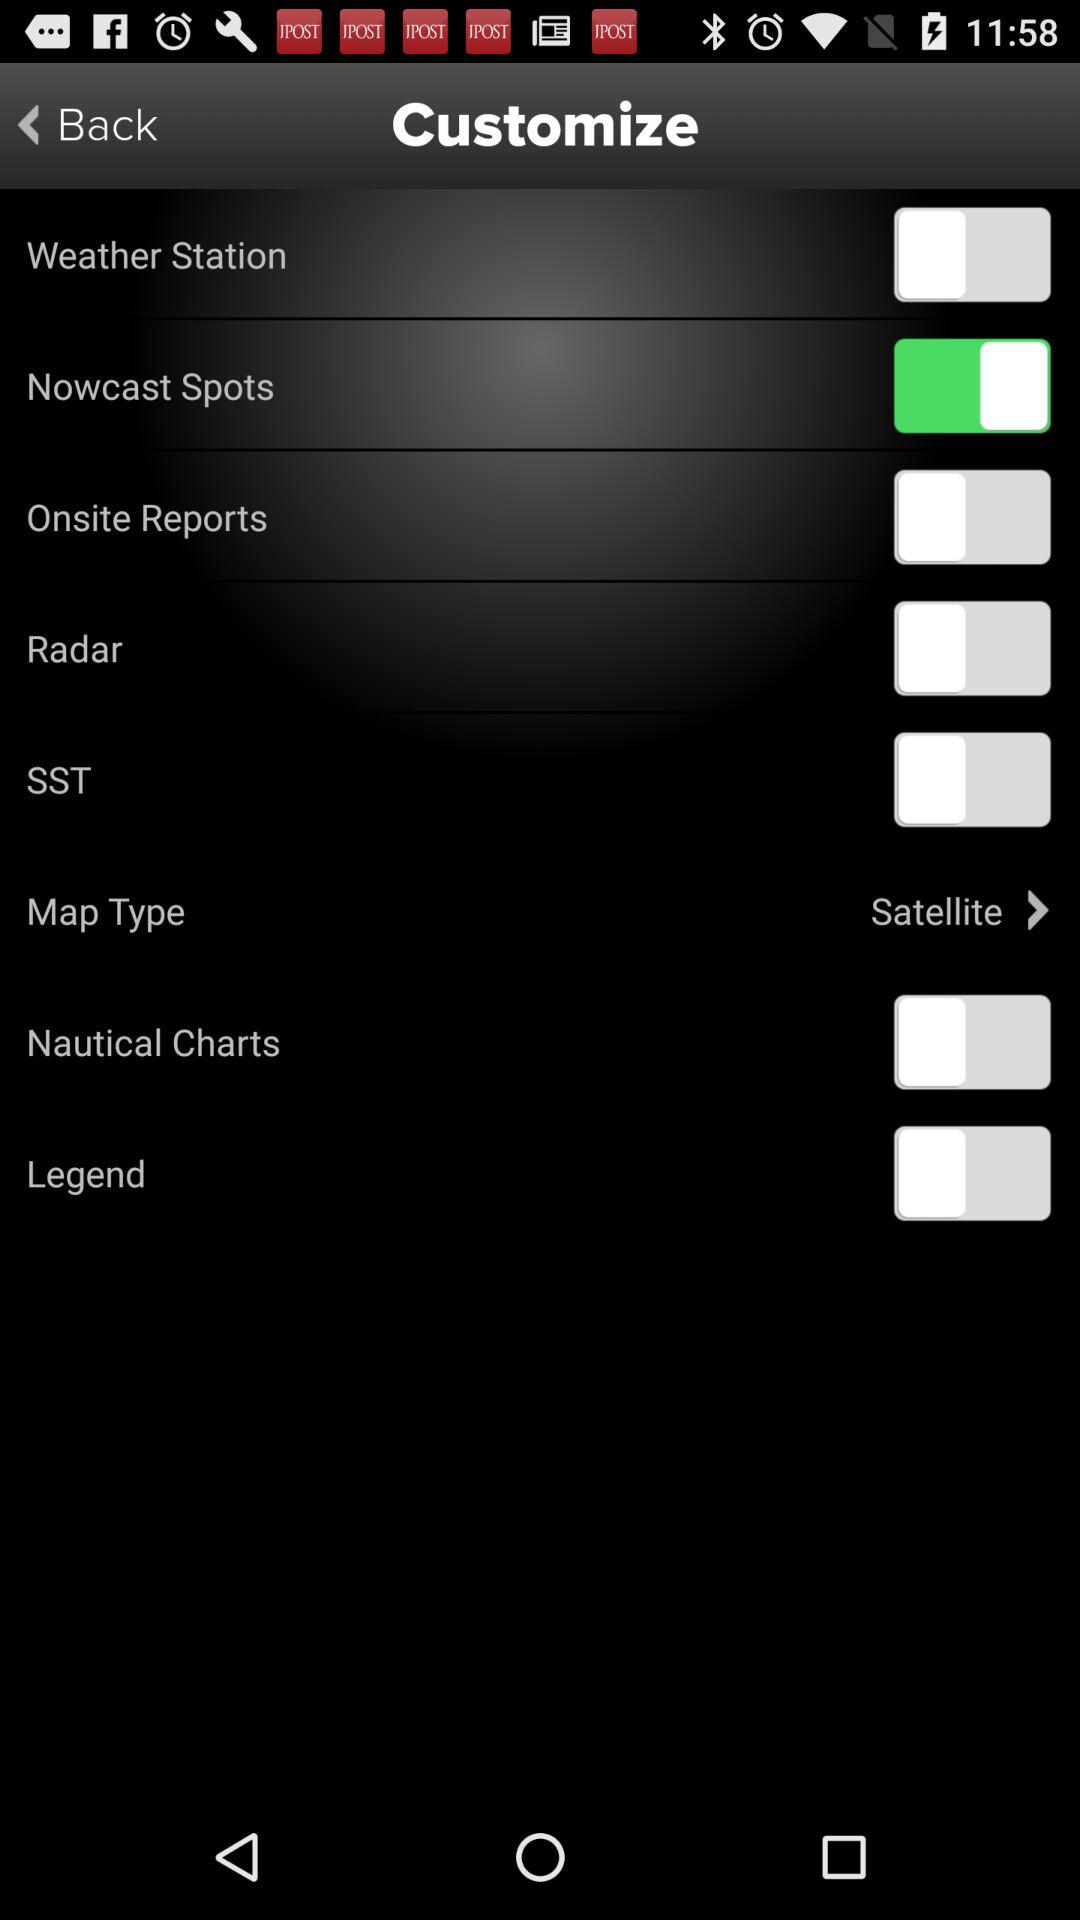What is the status of "Legend"? The status is "off". 